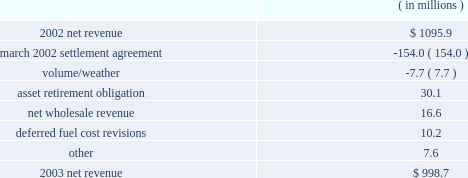Entergy arkansas , inc .
Management's financial discussion and analysis fuel and purchased power expenses increased primarily due to increased recovery of deferred fuel and purchased power costs primarily due to an increase in april 2004 in the energy cost recovery rider and the true-ups to the 2003 and 2002 energy cost recovery rider filings .
Other regulatory credits decreased primarily due to the over-recovery of grand gulf costs due to an increase in the grand gulf rider effective january 2004 .
2003 compared to 2002 net revenue , which is entergy arkansas' measure of gross margin , consists of operating revenues net of : 1 ) fuel , fuel-related , and purchased power expenses and 2 ) other regulatory credits .
Following is an analysis of the change in net revenue comparing 2003 to 2002. .
The march 2002 settlement agreement resolved a request for recovery of ice storm costs incurred in december 2000 with an offset of those costs for funds contributed to pay for future stranded costs .
A 1997 settlement provided for the collection of earnings in excess of an 11% ( 11 % ) return on equity in a transition cost account ( tca ) to offset stranded costs if retail open access were implemented .
In mid- and late december 2000 , two separate ice storms left 226000 and 212500 entergy arkansas customers , respectively , without electric power in its service area .
Entergy arkansas filed a proposal to recover costs plus carrying charges associated with power restoration caused by the ice storms .
Entergy arkansas' final storm damage cost determination reflected costs of approximately $ 195 million .
The apsc approved a settlement agreement submitted in march 2002 by entergy arkansas , the apsc staff , and the arkansas attorney general .
In the march 2002 settlement , the parties agreed that $ 153 million of the ice storm costs would be classified as incremental ice storm expenses that can be offset against the tca on a rate class basis , and any excess of ice storm costs over the amount available in the tca would be deferred and amortized over 30 years , although such excess costs were not allowed to be included as a separate component of rate base .
The allocated ice storm expenses exceeded the available tca funds by $ 15.8 million which was recorded as a regulatory asset in june 2002 .
In accordance with the settlement agreement and following the apsc's approval of the 2001 earnings review related to the tca , entergy arkansas filed to return $ 18.1 million of the tca to certain large general service class customers that paid more into the tca than their allocation of storm costs .
The apsc approved the return of funds to the large general service customer class in the form of refund checks in august 2002 .
As part of the implementation of the march 2002 settlement agreement provisions , the tca procedure ceased with the 2001 earnings evaluation .
Of the remaining ice storm costs , $ 32.2 million was addressed through established ratemaking procedures , including $ 22.2 million classified as capital additions , while $ 3.8 million of the ice storm costs was not recovered through rates .
The effect on net income of the march 2002 settlement agreement and 2001 earnings review was a $ 2.2 million increase in 2003 , because the decrease in net revenue was offset by the decrease in operation and maintenance expenses discussed below. .
What is the net change in net revenue during 2003 for entergy arkansas , inc.? 
Computations: (998.7 - 1095.9)
Answer: -97.2. 